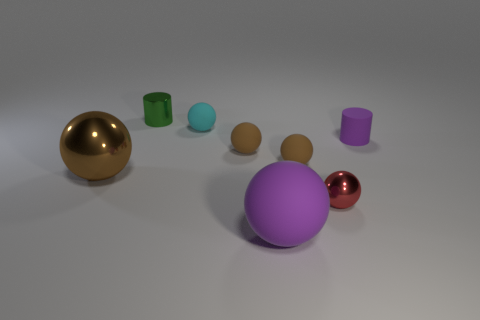What number of other things are the same color as the large matte ball?
Provide a succinct answer. 1. Does the purple object in front of the red thing have the same shape as the small shiny thing that is on the right side of the tiny green shiny object?
Make the answer very short. Yes. What number of blocks are either big brown objects or tiny brown rubber things?
Give a very brief answer. 0. Is the number of big metallic things that are behind the brown metallic sphere less than the number of purple balls?
Your response must be concise. Yes. What number of other things are made of the same material as the tiny cyan ball?
Offer a terse response. 4. Is the size of the red metallic sphere the same as the purple rubber cylinder?
Provide a succinct answer. Yes. What number of objects are either tiny green cylinders on the left side of the small red shiny thing or large cyan rubber things?
Your answer should be very brief. 1. There is a small object that is behind the cyan rubber object to the right of the green metallic thing; what is it made of?
Provide a short and direct response. Metal. Are there any large brown metal things that have the same shape as the big rubber thing?
Offer a terse response. Yes. Is the size of the red object the same as the cylinder to the left of the red shiny ball?
Ensure brevity in your answer.  Yes. 